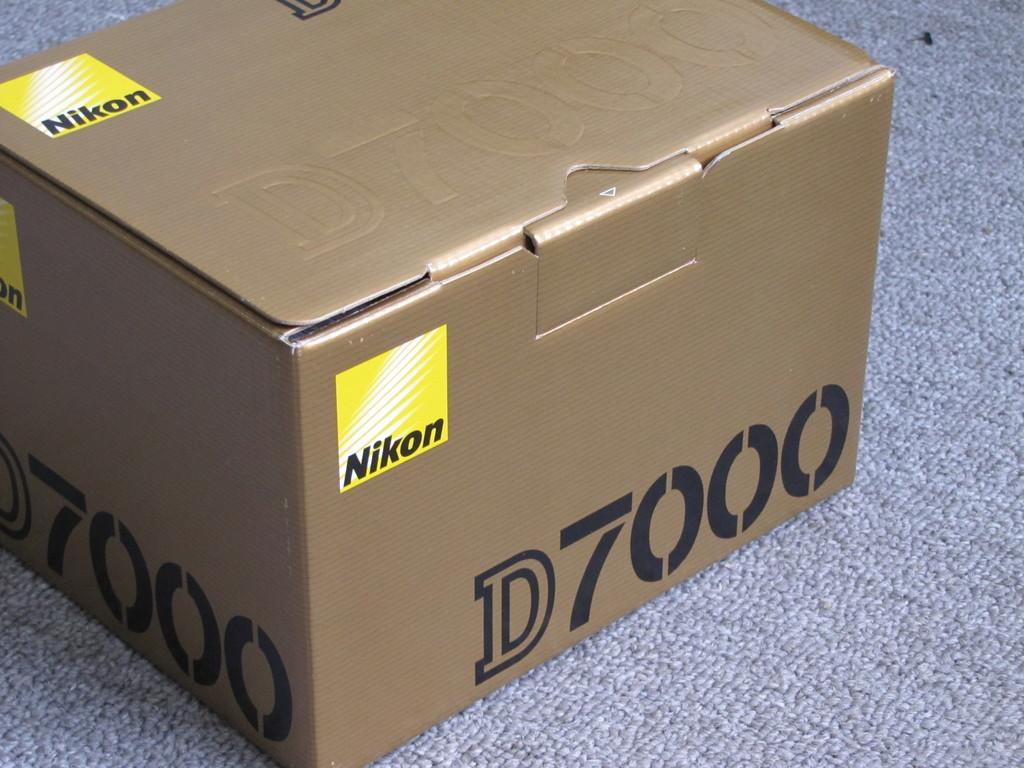<image>
Relay a brief, clear account of the picture shown. Nikon D7000 is labeled on this sealed, cardboard box. 